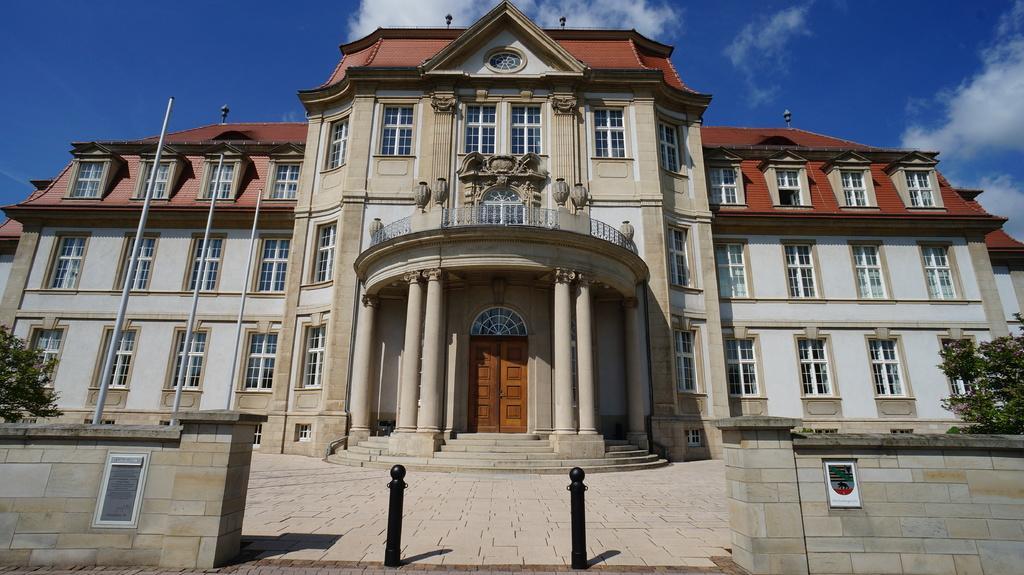How would you summarize this image in a sentence or two? In this image there is a building, there are poles and trees, and in the background there is sky. 